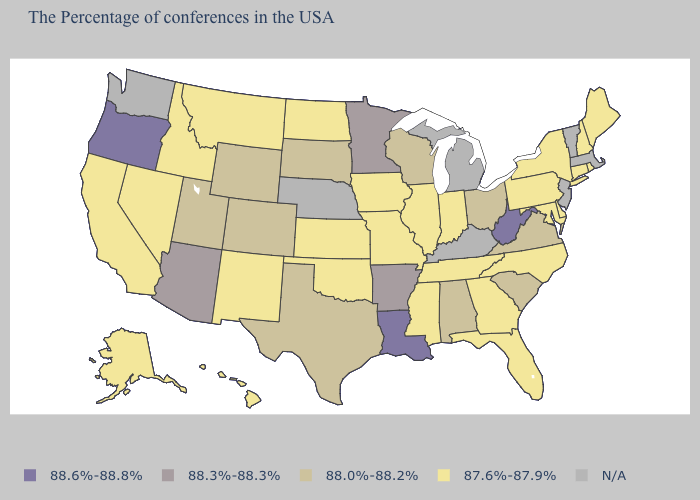Among the states that border Wyoming , does Idaho have the highest value?
Quick response, please. No. Does Ohio have the lowest value in the USA?
Concise answer only. No. How many symbols are there in the legend?
Answer briefly. 5. What is the value of Nevada?
Short answer required. 87.6%-87.9%. Which states have the highest value in the USA?
Write a very short answer. West Virginia, Louisiana, Oregon. What is the value of North Dakota?
Give a very brief answer. 87.6%-87.9%. What is the value of Georgia?
Give a very brief answer. 87.6%-87.9%. What is the value of Michigan?
Concise answer only. N/A. Does the first symbol in the legend represent the smallest category?
Write a very short answer. No. Does the first symbol in the legend represent the smallest category?
Give a very brief answer. No. Name the states that have a value in the range 88.0%-88.2%?
Short answer required. Virginia, South Carolina, Ohio, Alabama, Wisconsin, Texas, South Dakota, Wyoming, Colorado, Utah. What is the value of Nebraska?
Be succinct. N/A. What is the lowest value in the USA?
Quick response, please. 87.6%-87.9%. 